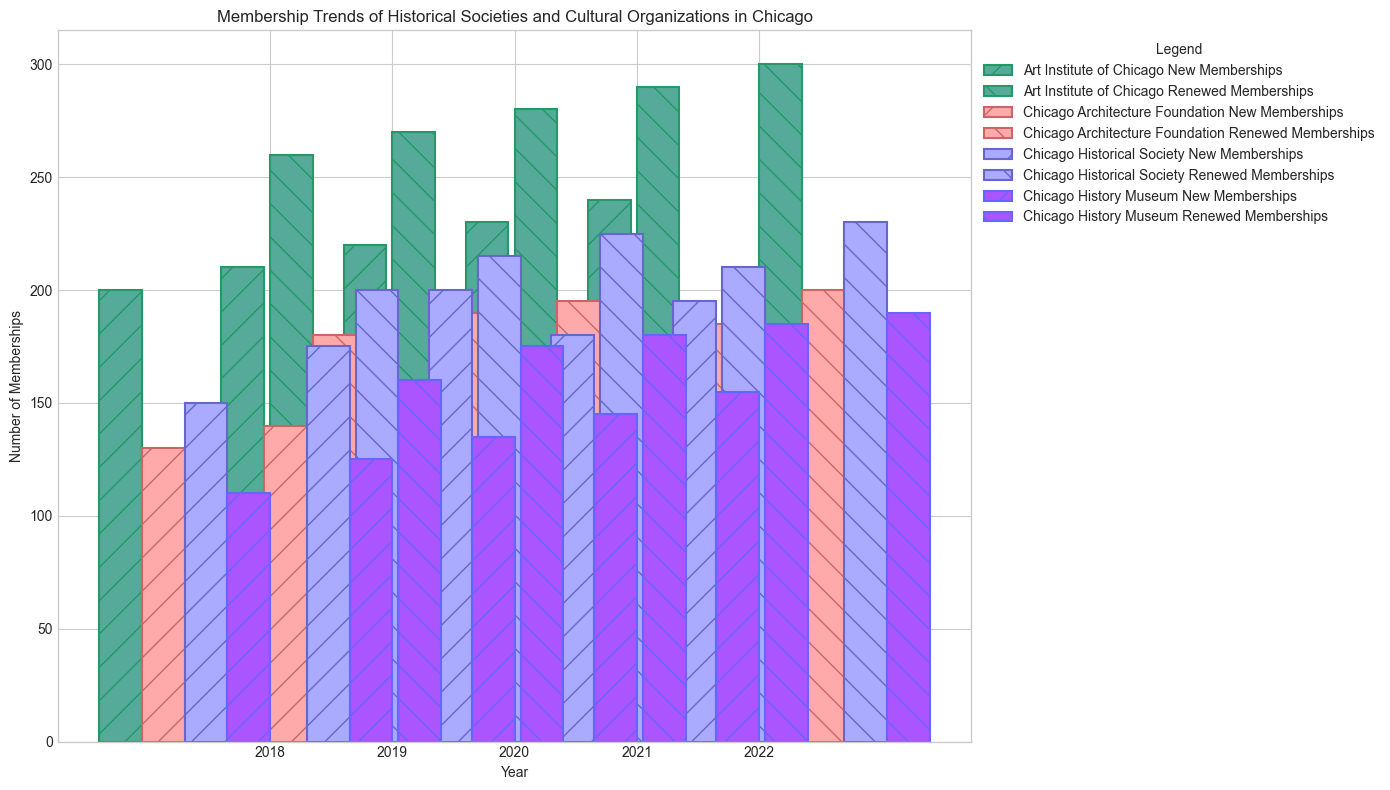Which organization had the highest number of new memberships in 2022? Look at the height of the bars for new memberships in 2022 and compare them across the organizations. The Art Institute of Chicago has the tallest bar for new memberships in 2022.
Answer: Art Institute of Chicago Which organization experienced the smallest difference in new memberships between 2018 and 2022? Calculate the difference in new memberships for each organization between 2018 and 2022. For the Chicago History Museum, the difference is 155-110=45; for the Chicago Historical Society, it is 195-150=45; for the Chicago Architecture Foundation, it is 170-130=40; and for the Art Institute of Chicago, it is 240-200=40. The smallest differences are for the Chicago Architecture Foundation and Art Institute of Chicago.
Answer: Chicago Architecture Foundation and Art Institute of Chicago What is the total number of renewed memberships for the Chicago Historical Society from 2018 to 2022? Sum the renewed memberships for each year from 2018 to 2022 for the Chicago Historical Society: 200 + 215 + 225 + 210 + 230 = 1080.
Answer: 1080 In which year did the Chicago Architecture Foundation have the highest combined total of new and renewed memberships? For each year, sum the new and renewed memberships for the Chicago Architecture Foundation. The totals are 2018: 130+180=310, 2019: 140+190=330, 2020: 160+195=355, 2021: 150+185=335, 2022: 170+200=370. 2022 has the highest total.
Answer: 2022 Which organization had the most consistent total (new + renewed) memberships over the years? Calculate the total memberships for each year for all organizations and analyze the variation. The Chicago History Museum totals are 2018: 270, 2019: 300, 2020: 315, 2021: 330, 2022: 345. The totals increase steadily each year compared to the other organizations which show more fluctuation.
Answer: Chicago History Museum By how much did the number of renewed memberships for the Art Institute of Chicago increase from 2018 to 2022? Subtract the number of renewed memberships in 2018 from the number in 2022 for the Art Institute of Chicago: 300 - 260 = 40.
Answer: 40 Was there any year when all organizations saw an increase in new memberships compared to the previous year? Compare the new memberships for each organization each year with the previous year. Only between 2019 and 2020 did all organizations see an increase: Chicago Historical Society (175 to 200), Chicago Architecture Foundation (140 to 160), Art Institute of Chicago (210 to 220), Chicago History Museum (125 to 135).
Answer: Yes, between 2019 and 2020 